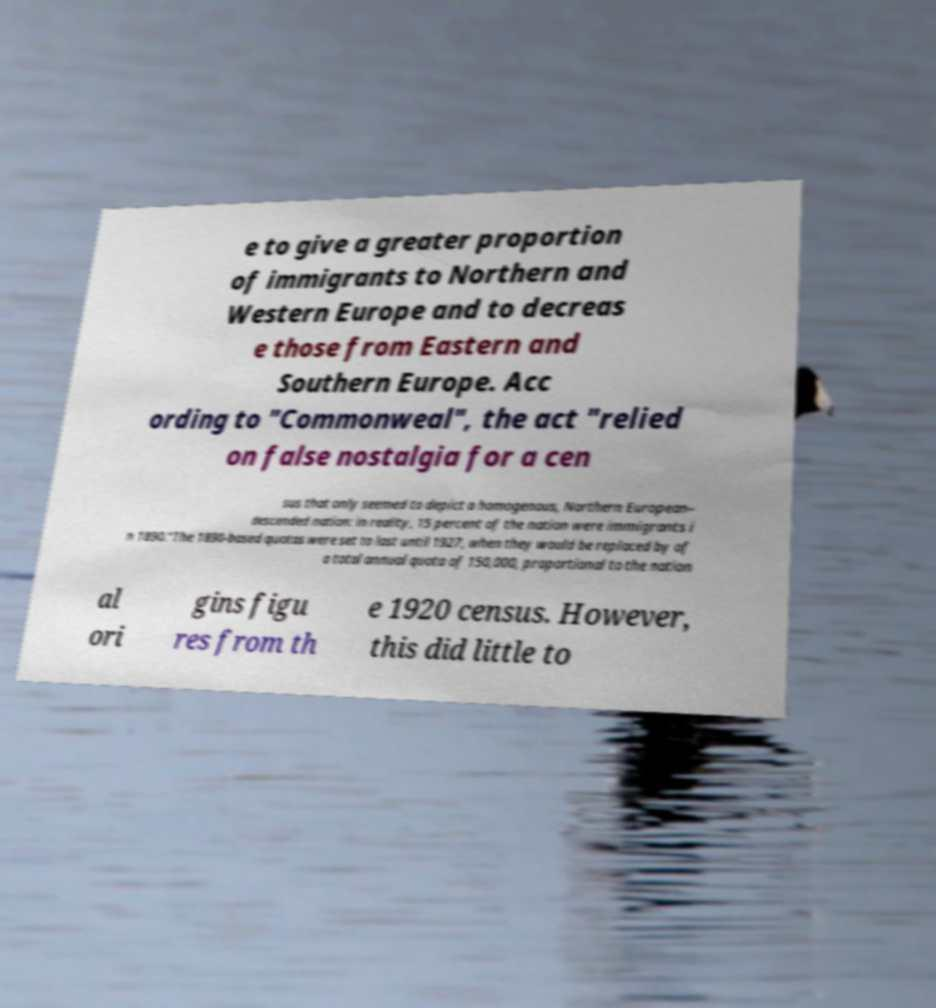For documentation purposes, I need the text within this image transcribed. Could you provide that? e to give a greater proportion of immigrants to Northern and Western Europe and to decreas e those from Eastern and Southern Europe. Acc ording to "Commonweal", the act "relied on false nostalgia for a cen sus that only seemed to depict a homogenous, Northern European– descended nation: in reality, 15 percent of the nation were immigrants i n 1890."The 1890-based quotas were set to last until 1927, when they would be replaced by of a total annual quota of 150,000, proportional to the nation al ori gins figu res from th e 1920 census. However, this did little to 